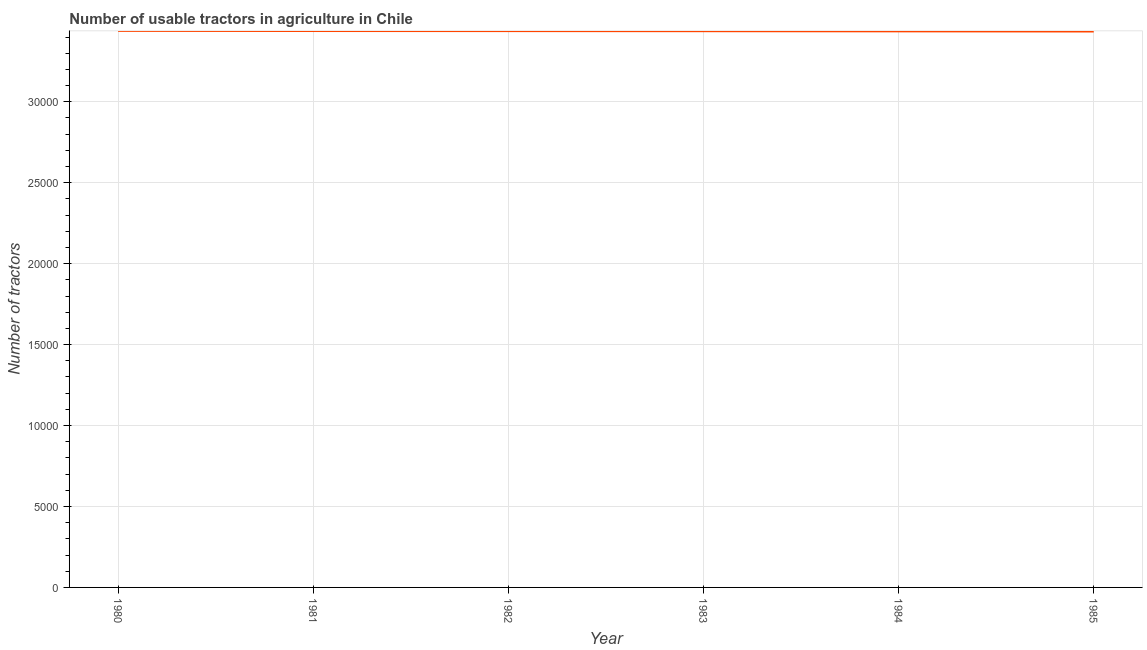What is the number of tractors in 1985?
Your response must be concise. 3.43e+04. Across all years, what is the maximum number of tractors?
Your answer should be compact. 3.44e+04. Across all years, what is the minimum number of tractors?
Your answer should be very brief. 3.43e+04. What is the sum of the number of tractors?
Your answer should be compact. 2.06e+05. What is the difference between the number of tractors in 1981 and 1982?
Your response must be concise. 5. What is the average number of tractors per year?
Provide a short and direct response. 3.44e+04. What is the median number of tractors?
Make the answer very short. 3.44e+04. In how many years, is the number of tractors greater than 30000 ?
Your response must be concise. 6. Do a majority of the years between 1983 and 1984 (inclusive) have number of tractors greater than 28000 ?
Provide a short and direct response. Yes. What is the ratio of the number of tractors in 1982 to that in 1985?
Keep it short and to the point. 1. Is the difference between the number of tractors in 1980 and 1981 greater than the difference between any two years?
Offer a terse response. No. What is the difference between the highest and the lowest number of tractors?
Offer a very short reply. 40. Does the number of tractors monotonically increase over the years?
Give a very brief answer. No. What is the difference between two consecutive major ticks on the Y-axis?
Provide a short and direct response. 5000. Are the values on the major ticks of Y-axis written in scientific E-notation?
Offer a very short reply. No. Does the graph contain grids?
Your answer should be compact. Yes. What is the title of the graph?
Provide a succinct answer. Number of usable tractors in agriculture in Chile. What is the label or title of the X-axis?
Your response must be concise. Year. What is the label or title of the Y-axis?
Keep it short and to the point. Number of tractors. What is the Number of tractors in 1980?
Give a very brief answer. 3.44e+04. What is the Number of tractors in 1981?
Make the answer very short. 3.44e+04. What is the Number of tractors in 1982?
Make the answer very short. 3.44e+04. What is the Number of tractors in 1983?
Provide a succinct answer. 3.44e+04. What is the Number of tractors in 1984?
Ensure brevity in your answer.  3.44e+04. What is the Number of tractors in 1985?
Provide a short and direct response. 3.43e+04. What is the difference between the Number of tractors in 1980 and 1982?
Provide a short and direct response. 15. What is the difference between the Number of tractors in 1980 and 1983?
Keep it short and to the point. 20. What is the difference between the Number of tractors in 1980 and 1984?
Offer a very short reply. 30. What is the difference between the Number of tractors in 1982 and 1983?
Your answer should be compact. 5. What is the difference between the Number of tractors in 1982 and 1984?
Provide a short and direct response. 15. What is the difference between the Number of tractors in 1982 and 1985?
Keep it short and to the point. 25. What is the ratio of the Number of tractors in 1980 to that in 1981?
Your response must be concise. 1. What is the ratio of the Number of tractors in 1980 to that in 1983?
Your response must be concise. 1. What is the ratio of the Number of tractors in 1981 to that in 1982?
Your answer should be compact. 1. What is the ratio of the Number of tractors in 1981 to that in 1985?
Your answer should be very brief. 1. What is the ratio of the Number of tractors in 1982 to that in 1985?
Provide a short and direct response. 1. What is the ratio of the Number of tractors in 1983 to that in 1984?
Provide a succinct answer. 1. What is the ratio of the Number of tractors in 1983 to that in 1985?
Keep it short and to the point. 1. 